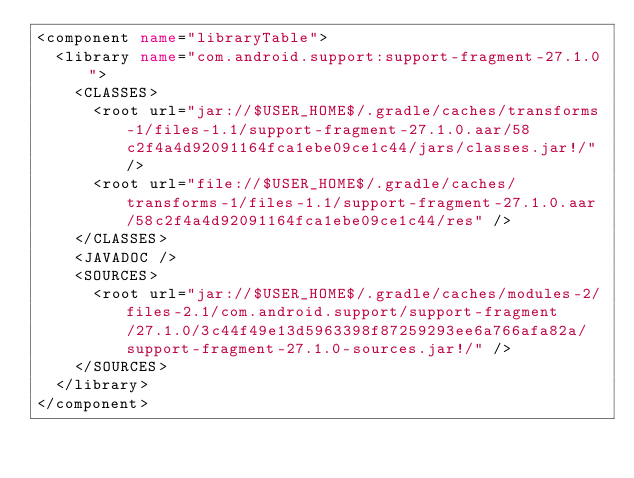<code> <loc_0><loc_0><loc_500><loc_500><_XML_><component name="libraryTable">
  <library name="com.android.support:support-fragment-27.1.0">
    <CLASSES>
      <root url="jar://$USER_HOME$/.gradle/caches/transforms-1/files-1.1/support-fragment-27.1.0.aar/58c2f4a4d92091164fca1ebe09ce1c44/jars/classes.jar!/" />
      <root url="file://$USER_HOME$/.gradle/caches/transforms-1/files-1.1/support-fragment-27.1.0.aar/58c2f4a4d92091164fca1ebe09ce1c44/res" />
    </CLASSES>
    <JAVADOC />
    <SOURCES>
      <root url="jar://$USER_HOME$/.gradle/caches/modules-2/files-2.1/com.android.support/support-fragment/27.1.0/3c44f49e13d5963398f87259293ee6a766afa82a/support-fragment-27.1.0-sources.jar!/" />
    </SOURCES>
  </library>
</component></code> 